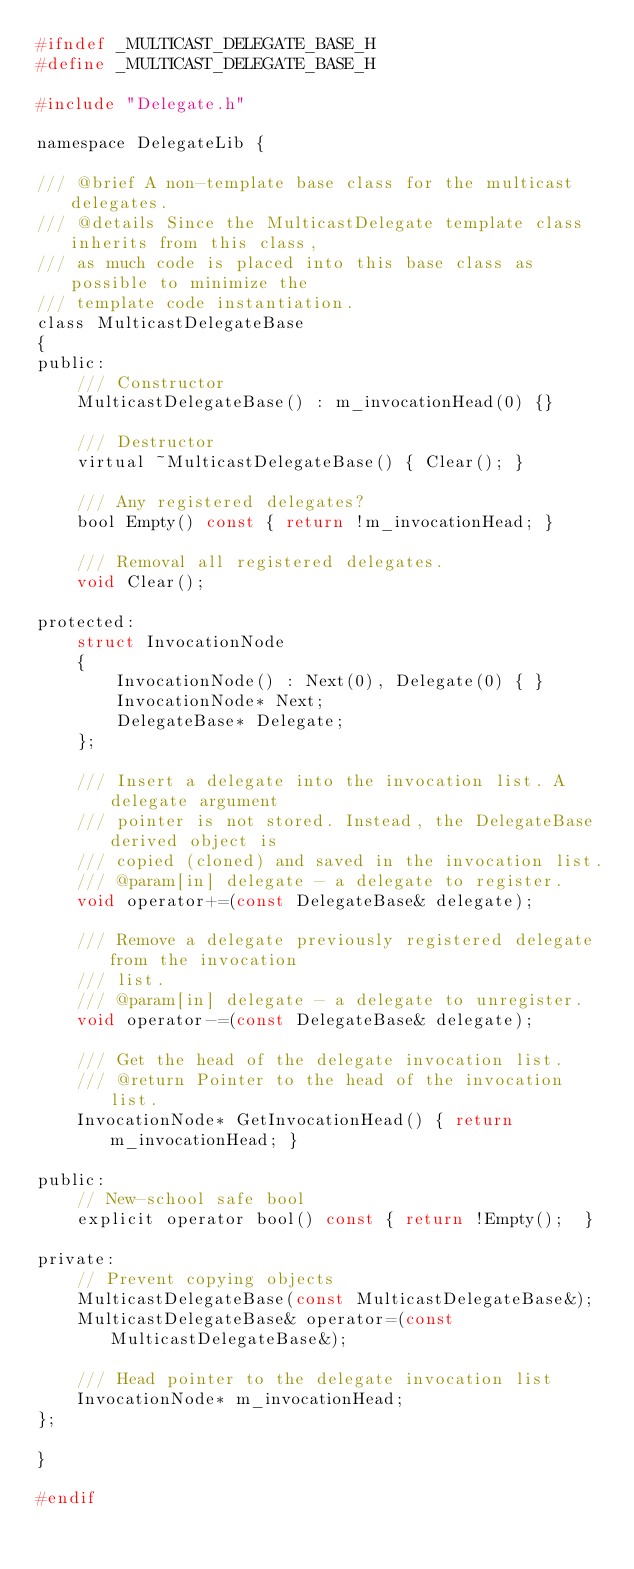Convert code to text. <code><loc_0><loc_0><loc_500><loc_500><_C_>#ifndef _MULTICAST_DELEGATE_BASE_H
#define _MULTICAST_DELEGATE_BASE_H

#include "Delegate.h"

namespace DelegateLib {

/// @brief A non-template base class for the multicast delegates. 
/// @details Since the MulticastDelegate template class inherits from this class, 
/// as much code is placed into this base class as possible to minimize the
/// template code instantiation. 
class MulticastDelegateBase
{
public:
	/// Constructor
	MulticastDelegateBase() : m_invocationHead(0) {}

	/// Destructor
	virtual ~MulticastDelegateBase() { Clear(); }

	/// Any registered delegates?
	bool Empty() const { return !m_invocationHead; }

	/// Removal all registered delegates.
	void Clear();

protected:
	struct InvocationNode
	{
		InvocationNode() : Next(0), Delegate(0) { }
		InvocationNode* Next;
		DelegateBase* Delegate;
	};

	/// Insert a delegate into the invocation list. A delegate argument 
	/// pointer is not stored. Instead, the DelegateBase derived object is 
	/// copied (cloned) and saved in the invocation list.
	/// @param[in] delegate - a delegate to register. 
	void operator+=(const DelegateBase& delegate);

	/// Remove a delegate previously registered delegate from the invocation
	/// list. 
	/// @param[in] delegate - a delegate to unregister. 
	void operator-=(const DelegateBase& delegate);

	/// Get the head of the delegate invocation list. 
	/// @return Pointer to the head of the invocation list. 
	InvocationNode* GetInvocationHead() { return m_invocationHead; }

public:
	// New-school safe bool
	explicit operator bool() const { return !Empty();  }

private:
	// Prevent copying objects
	MulticastDelegateBase(const MulticastDelegateBase&);
	MulticastDelegateBase& operator=(const MulticastDelegateBase&);

	/// Head pointer to the delegate invocation list
	InvocationNode* m_invocationHead;
};

}

#endif
</code> 